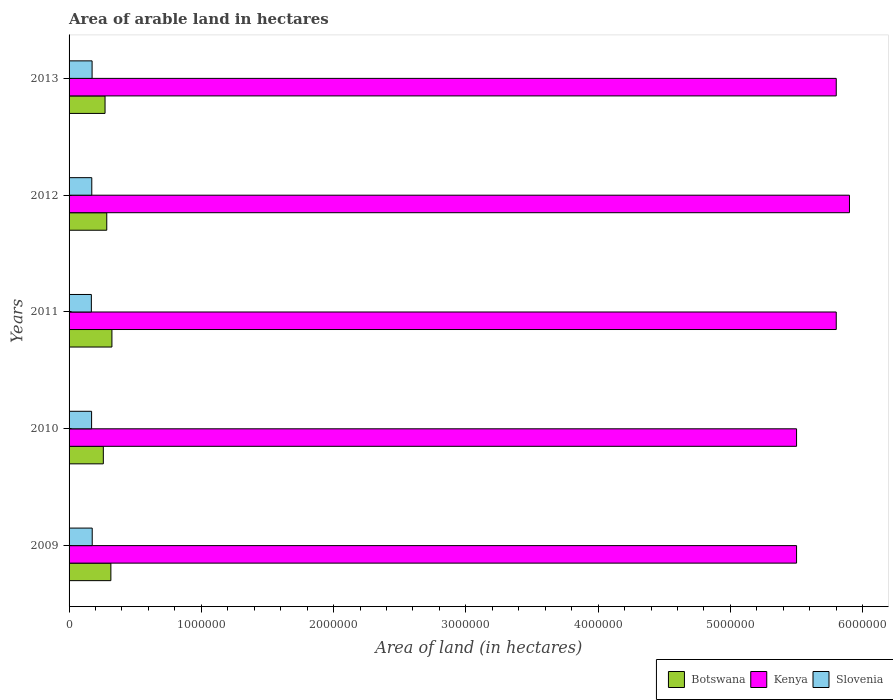Are the number of bars per tick equal to the number of legend labels?
Keep it short and to the point. Yes. How many bars are there on the 2nd tick from the top?
Keep it short and to the point. 3. In how many cases, is the number of bars for a given year not equal to the number of legend labels?
Your answer should be very brief. 0. What is the total arable land in Slovenia in 2009?
Provide a short and direct response. 1.75e+05. Across all years, what is the maximum total arable land in Botswana?
Provide a succinct answer. 3.24e+05. Across all years, what is the minimum total arable land in Slovenia?
Your response must be concise. 1.68e+05. In which year was the total arable land in Slovenia maximum?
Give a very brief answer. 2009. What is the total total arable land in Botswana in the graph?
Your answer should be very brief. 1.46e+06. What is the difference between the total arable land in Slovenia in 2010 and that in 2013?
Provide a succinct answer. -3800. What is the difference between the total arable land in Botswana in 2010 and the total arable land in Slovenia in 2013?
Offer a terse response. 8.49e+04. What is the average total arable land in Kenya per year?
Your answer should be compact. 5.70e+06. In the year 2011, what is the difference between the total arable land in Kenya and total arable land in Botswana?
Ensure brevity in your answer.  5.48e+06. In how many years, is the total arable land in Slovenia greater than 1800000 hectares?
Your answer should be very brief. 0. What is the ratio of the total arable land in Kenya in 2010 to that in 2011?
Provide a short and direct response. 0.95. Is the difference between the total arable land in Kenya in 2009 and 2011 greater than the difference between the total arable land in Botswana in 2009 and 2011?
Ensure brevity in your answer.  No. What is the difference between the highest and the second highest total arable land in Kenya?
Provide a succinct answer. 1.00e+05. What is the difference between the highest and the lowest total arable land in Slovenia?
Make the answer very short. 6500. What does the 3rd bar from the top in 2013 represents?
Keep it short and to the point. Botswana. What does the 3rd bar from the bottom in 2009 represents?
Offer a very short reply. Slovenia. Is it the case that in every year, the sum of the total arable land in Slovenia and total arable land in Botswana is greater than the total arable land in Kenya?
Your answer should be compact. No. How many bars are there?
Your response must be concise. 15. How many years are there in the graph?
Your answer should be very brief. 5. What is the difference between two consecutive major ticks on the X-axis?
Provide a succinct answer. 1.00e+06. Are the values on the major ticks of X-axis written in scientific E-notation?
Ensure brevity in your answer.  No. Does the graph contain any zero values?
Keep it short and to the point. No. How are the legend labels stacked?
Your response must be concise. Horizontal. What is the title of the graph?
Provide a short and direct response. Area of arable land in hectares. Does "Nigeria" appear as one of the legend labels in the graph?
Make the answer very short. No. What is the label or title of the X-axis?
Provide a succinct answer. Area of land (in hectares). What is the label or title of the Y-axis?
Your response must be concise. Years. What is the Area of land (in hectares) of Botswana in 2009?
Your response must be concise. 3.16e+05. What is the Area of land (in hectares) in Kenya in 2009?
Make the answer very short. 5.50e+06. What is the Area of land (in hectares) in Slovenia in 2009?
Offer a terse response. 1.75e+05. What is the Area of land (in hectares) of Botswana in 2010?
Offer a terse response. 2.59e+05. What is the Area of land (in hectares) of Kenya in 2010?
Provide a short and direct response. 5.50e+06. What is the Area of land (in hectares) of Slovenia in 2010?
Your answer should be compact. 1.70e+05. What is the Area of land (in hectares) in Botswana in 2011?
Keep it short and to the point. 3.24e+05. What is the Area of land (in hectares) in Kenya in 2011?
Ensure brevity in your answer.  5.80e+06. What is the Area of land (in hectares) of Slovenia in 2011?
Provide a short and direct response. 1.68e+05. What is the Area of land (in hectares) of Botswana in 2012?
Your answer should be compact. 2.85e+05. What is the Area of land (in hectares) in Kenya in 2012?
Give a very brief answer. 5.90e+06. What is the Area of land (in hectares) of Slovenia in 2012?
Your answer should be compact. 1.72e+05. What is the Area of land (in hectares) of Botswana in 2013?
Give a very brief answer. 2.72e+05. What is the Area of land (in hectares) in Kenya in 2013?
Offer a very short reply. 5.80e+06. What is the Area of land (in hectares) of Slovenia in 2013?
Keep it short and to the point. 1.74e+05. Across all years, what is the maximum Area of land (in hectares) of Botswana?
Provide a succinct answer. 3.24e+05. Across all years, what is the maximum Area of land (in hectares) in Kenya?
Your answer should be very brief. 5.90e+06. Across all years, what is the maximum Area of land (in hectares) of Slovenia?
Keep it short and to the point. 1.75e+05. Across all years, what is the minimum Area of land (in hectares) in Botswana?
Offer a very short reply. 2.59e+05. Across all years, what is the minimum Area of land (in hectares) of Kenya?
Your answer should be very brief. 5.50e+06. Across all years, what is the minimum Area of land (in hectares) of Slovenia?
Your response must be concise. 1.68e+05. What is the total Area of land (in hectares) of Botswana in the graph?
Offer a very short reply. 1.46e+06. What is the total Area of land (in hectares) of Kenya in the graph?
Your answer should be compact. 2.85e+07. What is the total Area of land (in hectares) in Slovenia in the graph?
Offer a terse response. 8.60e+05. What is the difference between the Area of land (in hectares) of Botswana in 2009 and that in 2010?
Give a very brief answer. 5.70e+04. What is the difference between the Area of land (in hectares) in Slovenia in 2009 and that in 2010?
Give a very brief answer. 4700. What is the difference between the Area of land (in hectares) of Botswana in 2009 and that in 2011?
Give a very brief answer. -8000. What is the difference between the Area of land (in hectares) of Slovenia in 2009 and that in 2011?
Provide a short and direct response. 6500. What is the difference between the Area of land (in hectares) of Botswana in 2009 and that in 2012?
Make the answer very short. 3.10e+04. What is the difference between the Area of land (in hectares) in Kenya in 2009 and that in 2012?
Ensure brevity in your answer.  -4.00e+05. What is the difference between the Area of land (in hectares) of Slovenia in 2009 and that in 2012?
Ensure brevity in your answer.  3300. What is the difference between the Area of land (in hectares) in Botswana in 2009 and that in 2013?
Ensure brevity in your answer.  4.40e+04. What is the difference between the Area of land (in hectares) of Kenya in 2009 and that in 2013?
Keep it short and to the point. -3.00e+05. What is the difference between the Area of land (in hectares) in Slovenia in 2009 and that in 2013?
Your answer should be very brief. 900. What is the difference between the Area of land (in hectares) of Botswana in 2010 and that in 2011?
Provide a succinct answer. -6.50e+04. What is the difference between the Area of land (in hectares) of Slovenia in 2010 and that in 2011?
Your response must be concise. 1800. What is the difference between the Area of land (in hectares) of Botswana in 2010 and that in 2012?
Provide a succinct answer. -2.60e+04. What is the difference between the Area of land (in hectares) in Kenya in 2010 and that in 2012?
Provide a succinct answer. -4.00e+05. What is the difference between the Area of land (in hectares) in Slovenia in 2010 and that in 2012?
Ensure brevity in your answer.  -1400. What is the difference between the Area of land (in hectares) in Botswana in 2010 and that in 2013?
Your answer should be compact. -1.30e+04. What is the difference between the Area of land (in hectares) in Kenya in 2010 and that in 2013?
Provide a succinct answer. -3.00e+05. What is the difference between the Area of land (in hectares) in Slovenia in 2010 and that in 2013?
Provide a short and direct response. -3800. What is the difference between the Area of land (in hectares) of Botswana in 2011 and that in 2012?
Offer a very short reply. 3.90e+04. What is the difference between the Area of land (in hectares) of Kenya in 2011 and that in 2012?
Offer a terse response. -1.00e+05. What is the difference between the Area of land (in hectares) of Slovenia in 2011 and that in 2012?
Give a very brief answer. -3200. What is the difference between the Area of land (in hectares) of Botswana in 2011 and that in 2013?
Ensure brevity in your answer.  5.20e+04. What is the difference between the Area of land (in hectares) of Kenya in 2011 and that in 2013?
Your answer should be compact. 0. What is the difference between the Area of land (in hectares) of Slovenia in 2011 and that in 2013?
Offer a very short reply. -5600. What is the difference between the Area of land (in hectares) in Botswana in 2012 and that in 2013?
Give a very brief answer. 1.30e+04. What is the difference between the Area of land (in hectares) in Kenya in 2012 and that in 2013?
Give a very brief answer. 1.00e+05. What is the difference between the Area of land (in hectares) of Slovenia in 2012 and that in 2013?
Give a very brief answer. -2400. What is the difference between the Area of land (in hectares) in Botswana in 2009 and the Area of land (in hectares) in Kenya in 2010?
Your answer should be compact. -5.18e+06. What is the difference between the Area of land (in hectares) of Botswana in 2009 and the Area of land (in hectares) of Slovenia in 2010?
Offer a terse response. 1.46e+05. What is the difference between the Area of land (in hectares) in Kenya in 2009 and the Area of land (in hectares) in Slovenia in 2010?
Keep it short and to the point. 5.33e+06. What is the difference between the Area of land (in hectares) of Botswana in 2009 and the Area of land (in hectares) of Kenya in 2011?
Give a very brief answer. -5.48e+06. What is the difference between the Area of land (in hectares) in Botswana in 2009 and the Area of land (in hectares) in Slovenia in 2011?
Your answer should be compact. 1.48e+05. What is the difference between the Area of land (in hectares) in Kenya in 2009 and the Area of land (in hectares) in Slovenia in 2011?
Your response must be concise. 5.33e+06. What is the difference between the Area of land (in hectares) of Botswana in 2009 and the Area of land (in hectares) of Kenya in 2012?
Offer a terse response. -5.58e+06. What is the difference between the Area of land (in hectares) in Botswana in 2009 and the Area of land (in hectares) in Slovenia in 2012?
Make the answer very short. 1.44e+05. What is the difference between the Area of land (in hectares) in Kenya in 2009 and the Area of land (in hectares) in Slovenia in 2012?
Make the answer very short. 5.33e+06. What is the difference between the Area of land (in hectares) of Botswana in 2009 and the Area of land (in hectares) of Kenya in 2013?
Make the answer very short. -5.48e+06. What is the difference between the Area of land (in hectares) in Botswana in 2009 and the Area of land (in hectares) in Slovenia in 2013?
Your response must be concise. 1.42e+05. What is the difference between the Area of land (in hectares) of Kenya in 2009 and the Area of land (in hectares) of Slovenia in 2013?
Ensure brevity in your answer.  5.33e+06. What is the difference between the Area of land (in hectares) of Botswana in 2010 and the Area of land (in hectares) of Kenya in 2011?
Give a very brief answer. -5.54e+06. What is the difference between the Area of land (in hectares) in Botswana in 2010 and the Area of land (in hectares) in Slovenia in 2011?
Offer a very short reply. 9.05e+04. What is the difference between the Area of land (in hectares) in Kenya in 2010 and the Area of land (in hectares) in Slovenia in 2011?
Offer a very short reply. 5.33e+06. What is the difference between the Area of land (in hectares) of Botswana in 2010 and the Area of land (in hectares) of Kenya in 2012?
Give a very brief answer. -5.64e+06. What is the difference between the Area of land (in hectares) in Botswana in 2010 and the Area of land (in hectares) in Slovenia in 2012?
Give a very brief answer. 8.73e+04. What is the difference between the Area of land (in hectares) in Kenya in 2010 and the Area of land (in hectares) in Slovenia in 2012?
Your answer should be very brief. 5.33e+06. What is the difference between the Area of land (in hectares) in Botswana in 2010 and the Area of land (in hectares) in Kenya in 2013?
Your response must be concise. -5.54e+06. What is the difference between the Area of land (in hectares) of Botswana in 2010 and the Area of land (in hectares) of Slovenia in 2013?
Offer a very short reply. 8.49e+04. What is the difference between the Area of land (in hectares) in Kenya in 2010 and the Area of land (in hectares) in Slovenia in 2013?
Provide a succinct answer. 5.33e+06. What is the difference between the Area of land (in hectares) in Botswana in 2011 and the Area of land (in hectares) in Kenya in 2012?
Your response must be concise. -5.58e+06. What is the difference between the Area of land (in hectares) of Botswana in 2011 and the Area of land (in hectares) of Slovenia in 2012?
Provide a short and direct response. 1.52e+05. What is the difference between the Area of land (in hectares) of Kenya in 2011 and the Area of land (in hectares) of Slovenia in 2012?
Make the answer very short. 5.63e+06. What is the difference between the Area of land (in hectares) of Botswana in 2011 and the Area of land (in hectares) of Kenya in 2013?
Ensure brevity in your answer.  -5.48e+06. What is the difference between the Area of land (in hectares) in Botswana in 2011 and the Area of land (in hectares) in Slovenia in 2013?
Make the answer very short. 1.50e+05. What is the difference between the Area of land (in hectares) of Kenya in 2011 and the Area of land (in hectares) of Slovenia in 2013?
Provide a succinct answer. 5.63e+06. What is the difference between the Area of land (in hectares) of Botswana in 2012 and the Area of land (in hectares) of Kenya in 2013?
Provide a succinct answer. -5.52e+06. What is the difference between the Area of land (in hectares) in Botswana in 2012 and the Area of land (in hectares) in Slovenia in 2013?
Ensure brevity in your answer.  1.11e+05. What is the difference between the Area of land (in hectares) of Kenya in 2012 and the Area of land (in hectares) of Slovenia in 2013?
Offer a terse response. 5.73e+06. What is the average Area of land (in hectares) in Botswana per year?
Your response must be concise. 2.91e+05. What is the average Area of land (in hectares) in Kenya per year?
Your response must be concise. 5.70e+06. What is the average Area of land (in hectares) in Slovenia per year?
Provide a succinct answer. 1.72e+05. In the year 2009, what is the difference between the Area of land (in hectares) of Botswana and Area of land (in hectares) of Kenya?
Offer a very short reply. -5.18e+06. In the year 2009, what is the difference between the Area of land (in hectares) in Botswana and Area of land (in hectares) in Slovenia?
Keep it short and to the point. 1.41e+05. In the year 2009, what is the difference between the Area of land (in hectares) of Kenya and Area of land (in hectares) of Slovenia?
Provide a short and direct response. 5.32e+06. In the year 2010, what is the difference between the Area of land (in hectares) of Botswana and Area of land (in hectares) of Kenya?
Your answer should be very brief. -5.24e+06. In the year 2010, what is the difference between the Area of land (in hectares) in Botswana and Area of land (in hectares) in Slovenia?
Offer a terse response. 8.87e+04. In the year 2010, what is the difference between the Area of land (in hectares) of Kenya and Area of land (in hectares) of Slovenia?
Provide a short and direct response. 5.33e+06. In the year 2011, what is the difference between the Area of land (in hectares) of Botswana and Area of land (in hectares) of Kenya?
Make the answer very short. -5.48e+06. In the year 2011, what is the difference between the Area of land (in hectares) of Botswana and Area of land (in hectares) of Slovenia?
Keep it short and to the point. 1.56e+05. In the year 2011, what is the difference between the Area of land (in hectares) of Kenya and Area of land (in hectares) of Slovenia?
Offer a very short reply. 5.63e+06. In the year 2012, what is the difference between the Area of land (in hectares) of Botswana and Area of land (in hectares) of Kenya?
Ensure brevity in your answer.  -5.62e+06. In the year 2012, what is the difference between the Area of land (in hectares) of Botswana and Area of land (in hectares) of Slovenia?
Your response must be concise. 1.13e+05. In the year 2012, what is the difference between the Area of land (in hectares) in Kenya and Area of land (in hectares) in Slovenia?
Your response must be concise. 5.73e+06. In the year 2013, what is the difference between the Area of land (in hectares) in Botswana and Area of land (in hectares) in Kenya?
Your answer should be compact. -5.53e+06. In the year 2013, what is the difference between the Area of land (in hectares) of Botswana and Area of land (in hectares) of Slovenia?
Offer a terse response. 9.79e+04. In the year 2013, what is the difference between the Area of land (in hectares) in Kenya and Area of land (in hectares) in Slovenia?
Your answer should be very brief. 5.63e+06. What is the ratio of the Area of land (in hectares) of Botswana in 2009 to that in 2010?
Ensure brevity in your answer.  1.22. What is the ratio of the Area of land (in hectares) in Slovenia in 2009 to that in 2010?
Make the answer very short. 1.03. What is the ratio of the Area of land (in hectares) of Botswana in 2009 to that in 2011?
Offer a terse response. 0.98. What is the ratio of the Area of land (in hectares) of Kenya in 2009 to that in 2011?
Keep it short and to the point. 0.95. What is the ratio of the Area of land (in hectares) in Slovenia in 2009 to that in 2011?
Provide a succinct answer. 1.04. What is the ratio of the Area of land (in hectares) of Botswana in 2009 to that in 2012?
Your answer should be very brief. 1.11. What is the ratio of the Area of land (in hectares) of Kenya in 2009 to that in 2012?
Keep it short and to the point. 0.93. What is the ratio of the Area of land (in hectares) in Slovenia in 2009 to that in 2012?
Your answer should be very brief. 1.02. What is the ratio of the Area of land (in hectares) of Botswana in 2009 to that in 2013?
Give a very brief answer. 1.16. What is the ratio of the Area of land (in hectares) of Kenya in 2009 to that in 2013?
Ensure brevity in your answer.  0.95. What is the ratio of the Area of land (in hectares) of Slovenia in 2009 to that in 2013?
Offer a very short reply. 1.01. What is the ratio of the Area of land (in hectares) of Botswana in 2010 to that in 2011?
Provide a short and direct response. 0.8. What is the ratio of the Area of land (in hectares) of Kenya in 2010 to that in 2011?
Give a very brief answer. 0.95. What is the ratio of the Area of land (in hectares) in Slovenia in 2010 to that in 2011?
Make the answer very short. 1.01. What is the ratio of the Area of land (in hectares) in Botswana in 2010 to that in 2012?
Your answer should be compact. 0.91. What is the ratio of the Area of land (in hectares) in Kenya in 2010 to that in 2012?
Your response must be concise. 0.93. What is the ratio of the Area of land (in hectares) in Slovenia in 2010 to that in 2012?
Your answer should be compact. 0.99. What is the ratio of the Area of land (in hectares) in Botswana in 2010 to that in 2013?
Provide a short and direct response. 0.95. What is the ratio of the Area of land (in hectares) in Kenya in 2010 to that in 2013?
Ensure brevity in your answer.  0.95. What is the ratio of the Area of land (in hectares) of Slovenia in 2010 to that in 2013?
Give a very brief answer. 0.98. What is the ratio of the Area of land (in hectares) in Botswana in 2011 to that in 2012?
Ensure brevity in your answer.  1.14. What is the ratio of the Area of land (in hectares) in Kenya in 2011 to that in 2012?
Your response must be concise. 0.98. What is the ratio of the Area of land (in hectares) in Slovenia in 2011 to that in 2012?
Your answer should be very brief. 0.98. What is the ratio of the Area of land (in hectares) in Botswana in 2011 to that in 2013?
Keep it short and to the point. 1.19. What is the ratio of the Area of land (in hectares) of Kenya in 2011 to that in 2013?
Give a very brief answer. 1. What is the ratio of the Area of land (in hectares) in Slovenia in 2011 to that in 2013?
Your answer should be compact. 0.97. What is the ratio of the Area of land (in hectares) of Botswana in 2012 to that in 2013?
Make the answer very short. 1.05. What is the ratio of the Area of land (in hectares) of Kenya in 2012 to that in 2013?
Your answer should be very brief. 1.02. What is the ratio of the Area of land (in hectares) of Slovenia in 2012 to that in 2013?
Your answer should be very brief. 0.99. What is the difference between the highest and the second highest Area of land (in hectares) of Botswana?
Your answer should be very brief. 8000. What is the difference between the highest and the second highest Area of land (in hectares) of Slovenia?
Offer a very short reply. 900. What is the difference between the highest and the lowest Area of land (in hectares) in Botswana?
Give a very brief answer. 6.50e+04. What is the difference between the highest and the lowest Area of land (in hectares) of Slovenia?
Your answer should be compact. 6500. 